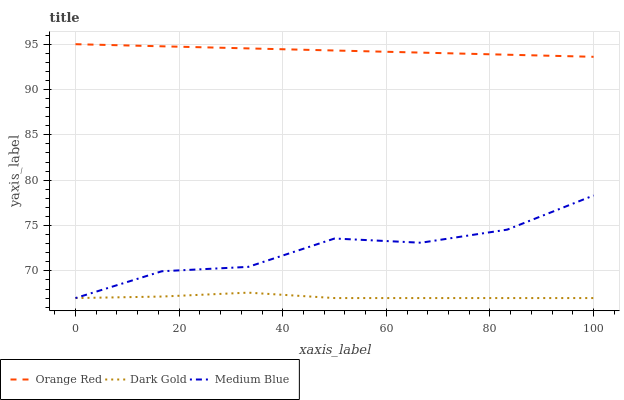Does Dark Gold have the minimum area under the curve?
Answer yes or no. Yes. Does Orange Red have the maximum area under the curve?
Answer yes or no. Yes. Does Orange Red have the minimum area under the curve?
Answer yes or no. No. Does Dark Gold have the maximum area under the curve?
Answer yes or no. No. Is Orange Red the smoothest?
Answer yes or no. Yes. Is Medium Blue the roughest?
Answer yes or no. Yes. Is Dark Gold the smoothest?
Answer yes or no. No. Is Dark Gold the roughest?
Answer yes or no. No. Does Medium Blue have the lowest value?
Answer yes or no. Yes. Does Orange Red have the lowest value?
Answer yes or no. No. Does Orange Red have the highest value?
Answer yes or no. Yes. Does Dark Gold have the highest value?
Answer yes or no. No. Is Medium Blue less than Orange Red?
Answer yes or no. Yes. Is Orange Red greater than Medium Blue?
Answer yes or no. Yes. Does Dark Gold intersect Medium Blue?
Answer yes or no. Yes. Is Dark Gold less than Medium Blue?
Answer yes or no. No. Is Dark Gold greater than Medium Blue?
Answer yes or no. No. Does Medium Blue intersect Orange Red?
Answer yes or no. No. 